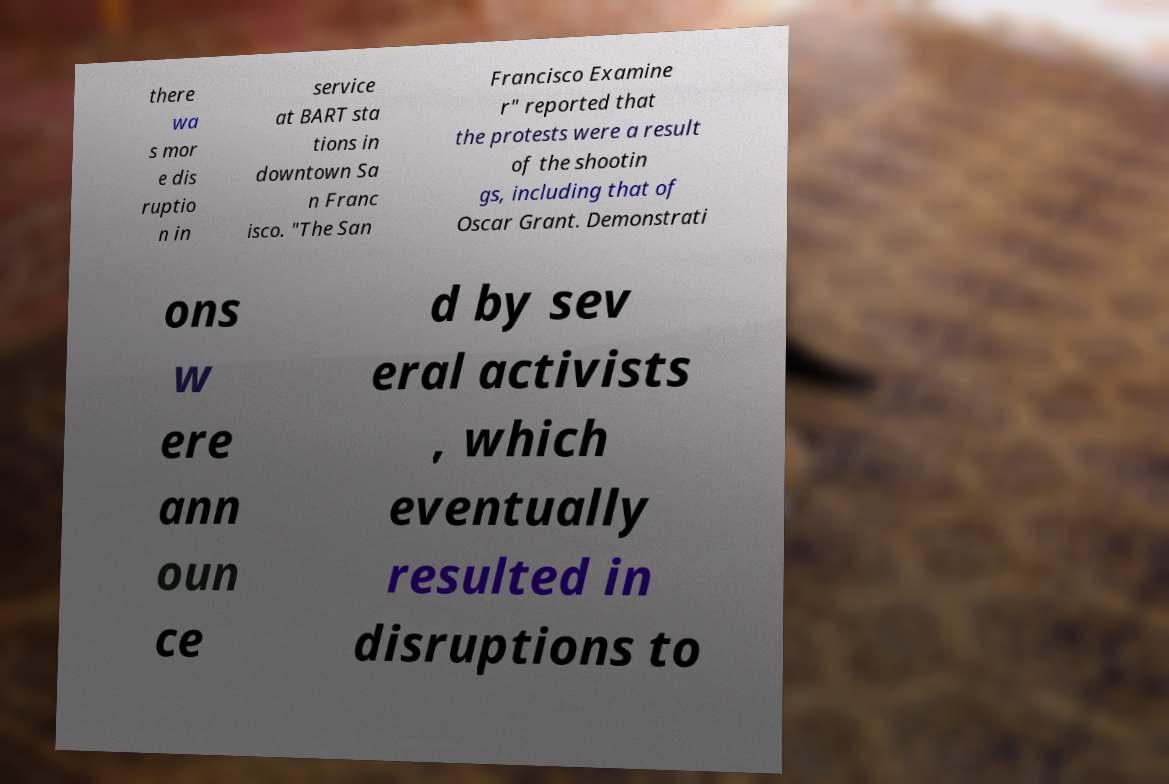Could you extract and type out the text from this image? there wa s mor e dis ruptio n in service at BART sta tions in downtown Sa n Franc isco. "The San Francisco Examine r" reported that the protests were a result of the shootin gs, including that of Oscar Grant. Demonstrati ons w ere ann oun ce d by sev eral activists , which eventually resulted in disruptions to 